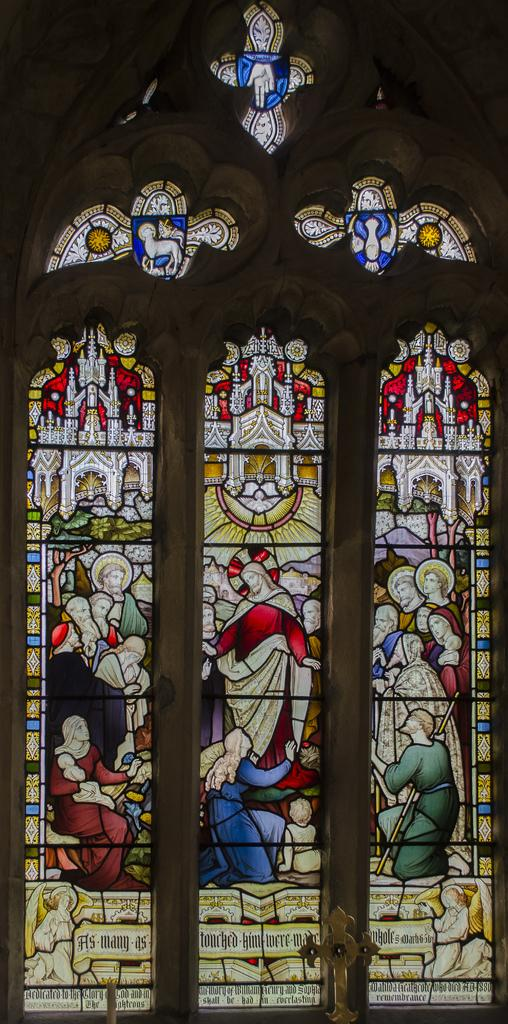What type of architectural feature can be seen in the image? There are windows in the image. What is happening on the windows? People are visible on the windows. Are there any additional elements on the windows besides the people? Yes, symbols and text are present on the windows. Can you describe the design of the wings on the people in the image? There are no wings present on the people in the image; they are standing on the windows. 